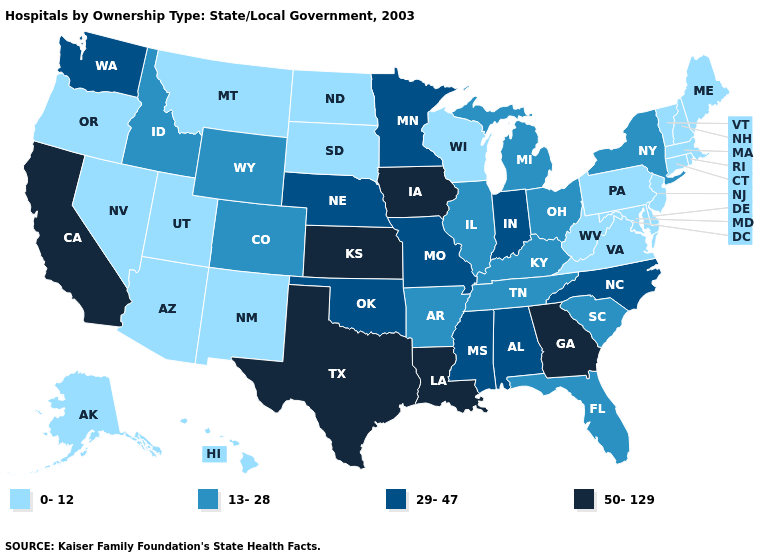How many symbols are there in the legend?
Be succinct. 4. How many symbols are there in the legend?
Give a very brief answer. 4. What is the lowest value in states that border Rhode Island?
Concise answer only. 0-12. How many symbols are there in the legend?
Give a very brief answer. 4. What is the highest value in the USA?
Concise answer only. 50-129. What is the value of California?
Answer briefly. 50-129. How many symbols are there in the legend?
Write a very short answer. 4. Among the states that border New Jersey , does New York have the highest value?
Be succinct. Yes. Name the states that have a value in the range 13-28?
Keep it brief. Arkansas, Colorado, Florida, Idaho, Illinois, Kentucky, Michigan, New York, Ohio, South Carolina, Tennessee, Wyoming. Does Florida have the lowest value in the USA?
Keep it brief. No. What is the lowest value in the MidWest?
Be succinct. 0-12. What is the lowest value in states that border New Jersey?
Write a very short answer. 0-12. Does Ohio have the highest value in the MidWest?
Answer briefly. No. What is the value of New Mexico?
Quick response, please. 0-12. Among the states that border Ohio , does Kentucky have the highest value?
Give a very brief answer. No. 